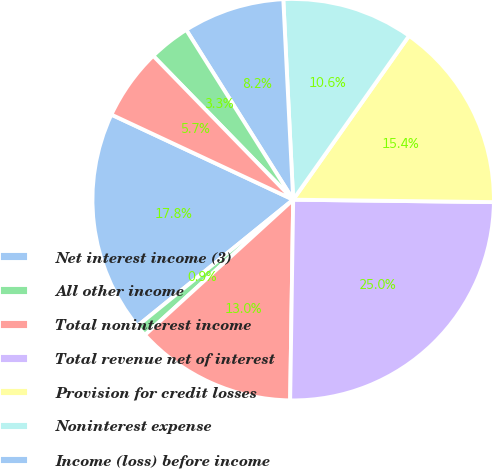Convert chart to OTSL. <chart><loc_0><loc_0><loc_500><loc_500><pie_chart><fcel>Net interest income (3)<fcel>All other income<fcel>Total noninterest income<fcel>Total revenue net of interest<fcel>Provision for credit losses<fcel>Noninterest expense<fcel>Income (loss) before income<fcel>Income tax expense (benefit)<fcel>Net income<nl><fcel>17.81%<fcel>0.93%<fcel>12.99%<fcel>25.05%<fcel>15.4%<fcel>10.58%<fcel>8.16%<fcel>3.34%<fcel>5.75%<nl></chart> 